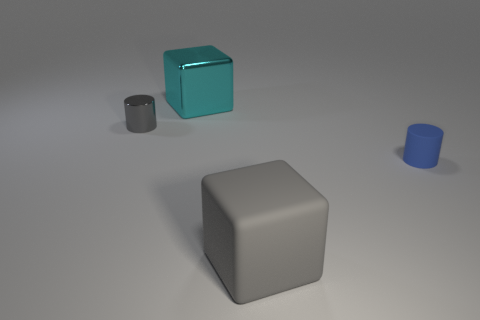Add 2 big cyan objects. How many objects exist? 6 Subtract all gray cylinders. How many cylinders are left? 1 Subtract 1 cubes. How many cubes are left? 1 Subtract all small cyan shiny spheres. Subtract all shiny objects. How many objects are left? 2 Add 3 blue matte things. How many blue matte things are left? 4 Add 2 big gray metal cylinders. How many big gray metal cylinders exist? 2 Subtract 0 gray balls. How many objects are left? 4 Subtract all cyan cubes. Subtract all green spheres. How many cubes are left? 1 Subtract all gray blocks. How many gray cylinders are left? 1 